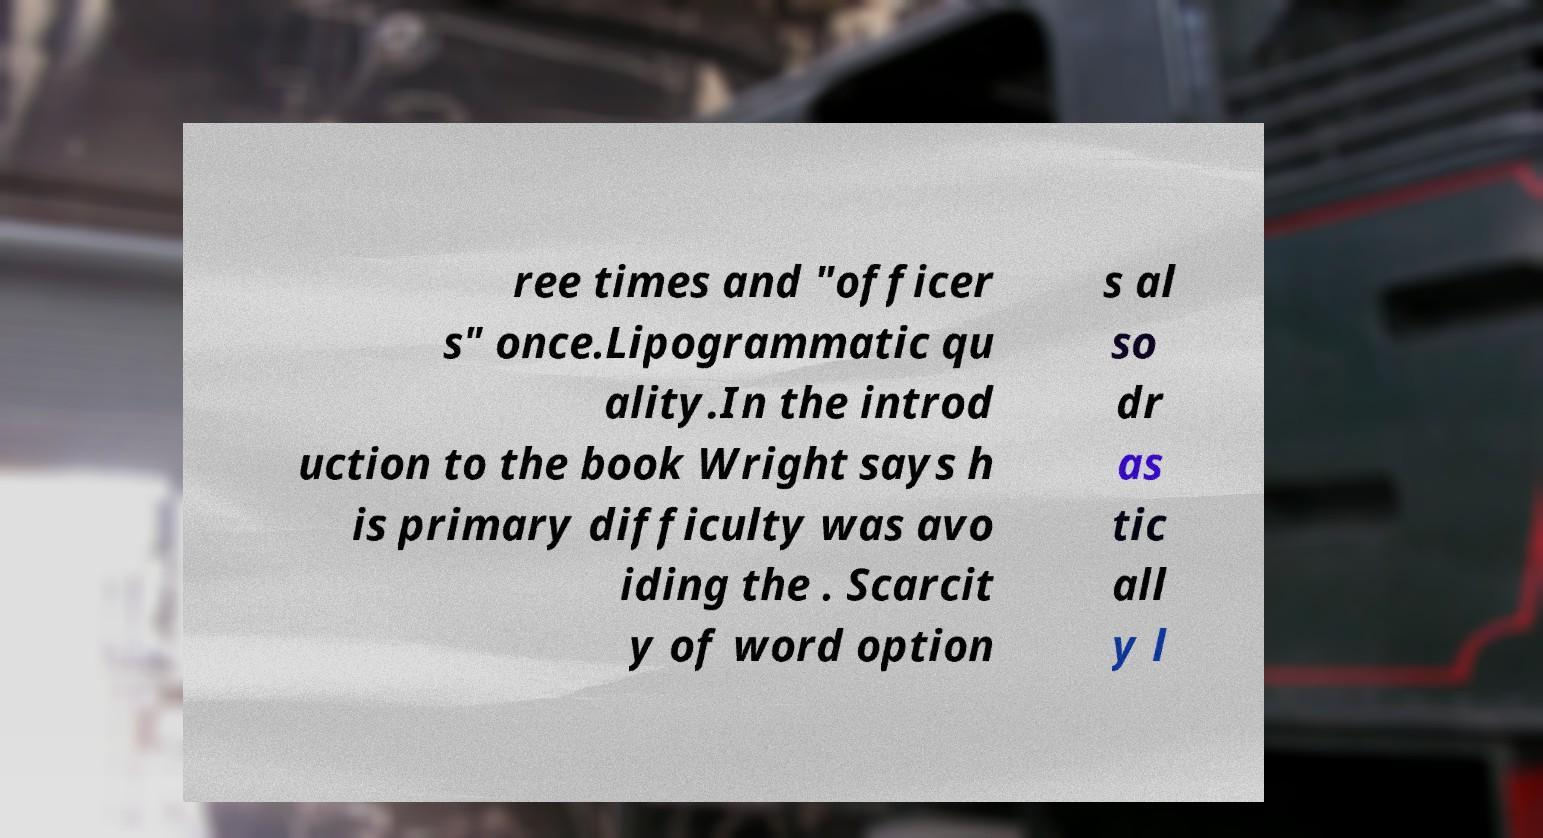Could you extract and type out the text from this image? ree times and "officer s" once.Lipogrammatic qu ality.In the introd uction to the book Wright says h is primary difficulty was avo iding the . Scarcit y of word option s al so dr as tic all y l 